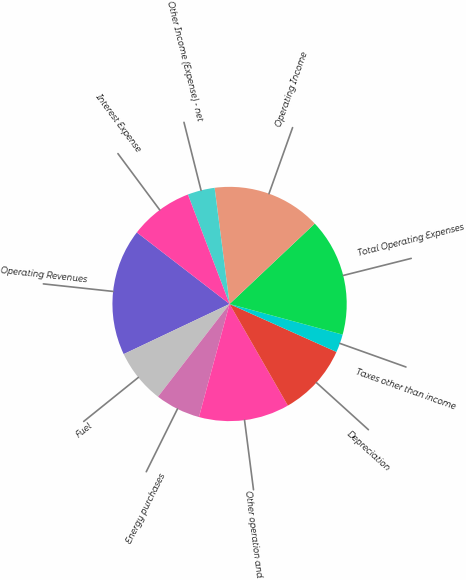<chart> <loc_0><loc_0><loc_500><loc_500><pie_chart><fcel>Operating Revenues<fcel>Fuel<fcel>Energy purchases<fcel>Other operation and<fcel>Depreciation<fcel>Taxes other than income<fcel>Total Operating Expenses<fcel>Operating Income<fcel>Other Income (Expense) - net<fcel>Interest Expense<nl><fcel>17.5%<fcel>7.5%<fcel>6.25%<fcel>12.5%<fcel>10.0%<fcel>2.5%<fcel>16.25%<fcel>15.0%<fcel>3.75%<fcel>8.75%<nl></chart> 